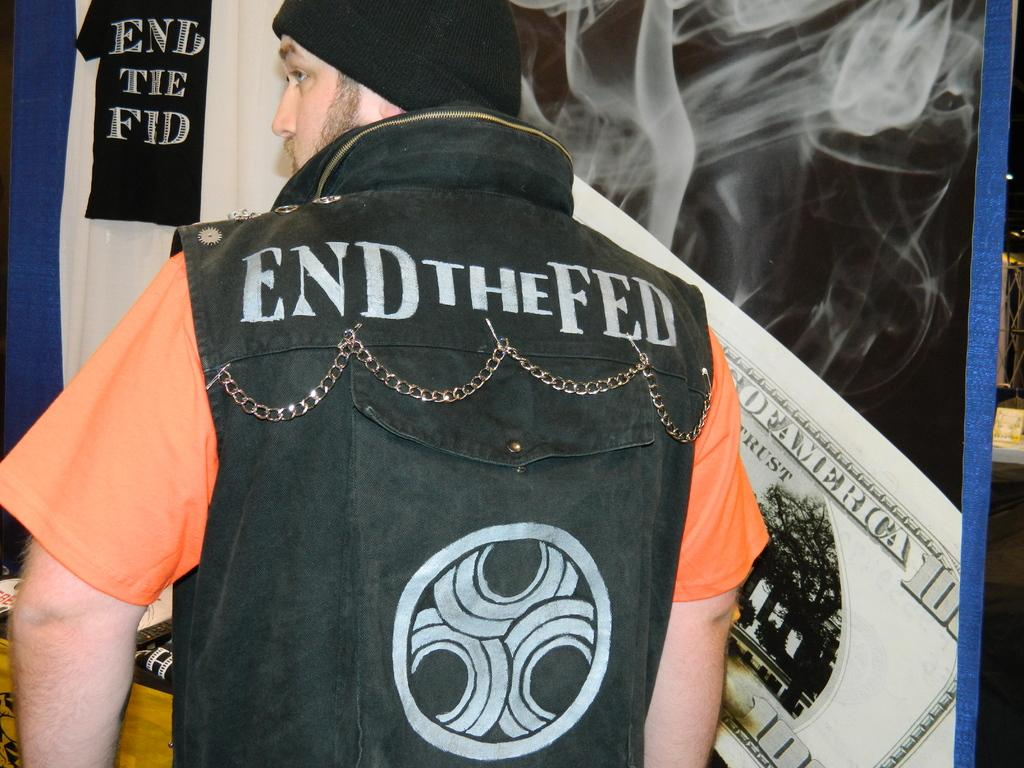<image>
Create a compact narrative representing the image presented. A man wears a black vest that says End the Fed on the back. 